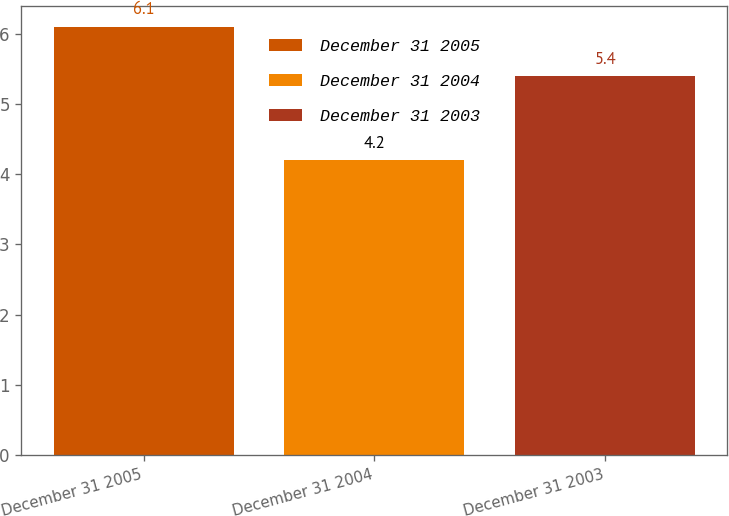<chart> <loc_0><loc_0><loc_500><loc_500><bar_chart><fcel>December 31 2005<fcel>December 31 2004<fcel>December 31 2003<nl><fcel>6.1<fcel>4.2<fcel>5.4<nl></chart> 